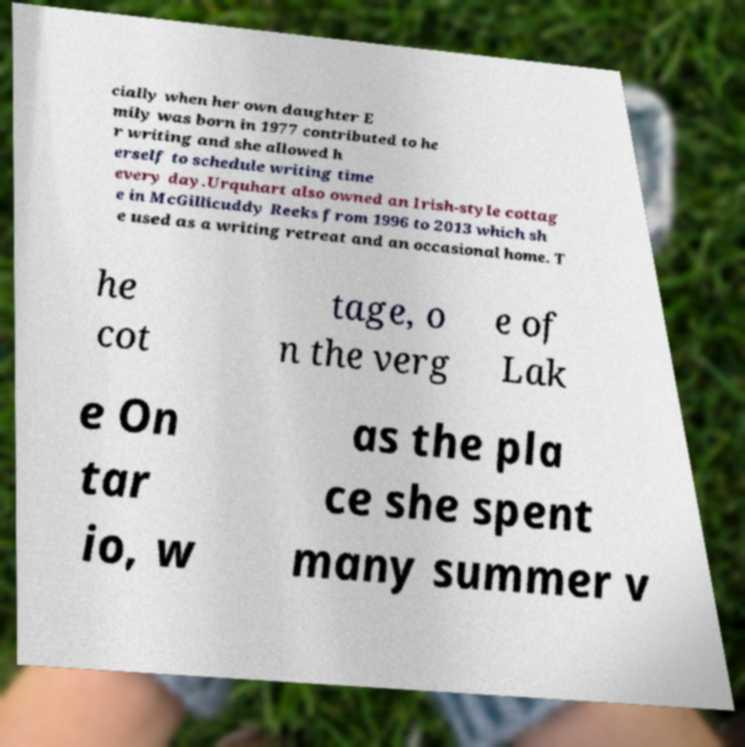Can you accurately transcribe the text from the provided image for me? cially when her own daughter E mily was born in 1977 contributed to he r writing and she allowed h erself to schedule writing time every day.Urquhart also owned an Irish-style cottag e in McGillicuddy Reeks from 1996 to 2013 which sh e used as a writing retreat and an occasional home. T he cot tage, o n the verg e of Lak e On tar io, w as the pla ce she spent many summer v 